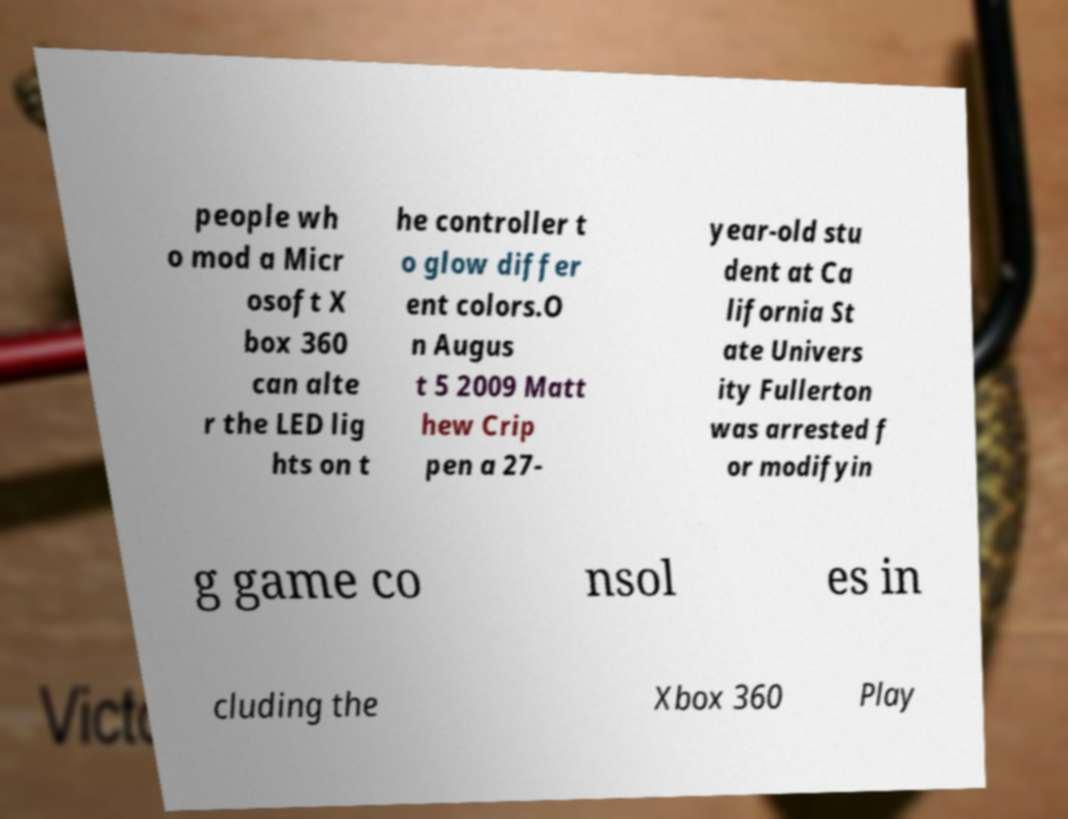What messages or text are displayed in this image? I need them in a readable, typed format. people wh o mod a Micr osoft X box 360 can alte r the LED lig hts on t he controller t o glow differ ent colors.O n Augus t 5 2009 Matt hew Crip pen a 27- year-old stu dent at Ca lifornia St ate Univers ity Fullerton was arrested f or modifyin g game co nsol es in cluding the Xbox 360 Play 